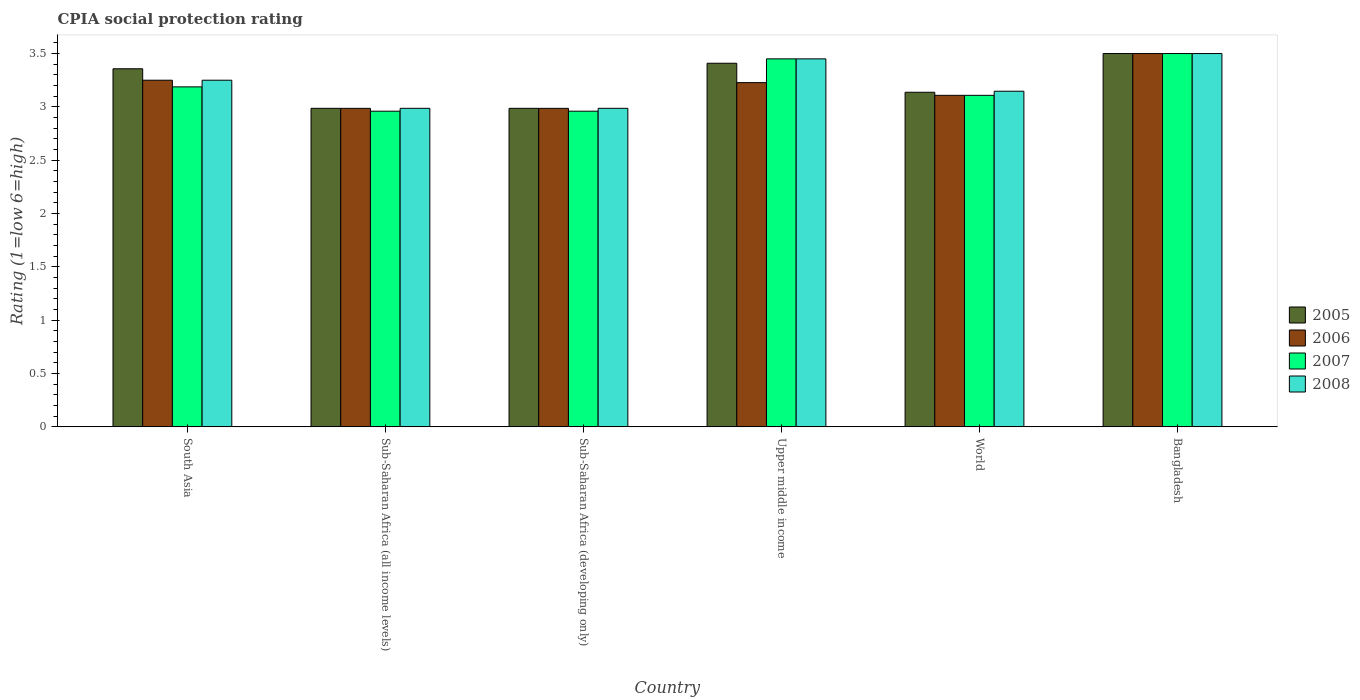Are the number of bars on each tick of the X-axis equal?
Offer a terse response. Yes. How many bars are there on the 4th tick from the right?
Offer a very short reply. 4. What is the label of the 5th group of bars from the left?
Offer a terse response. World. In how many cases, is the number of bars for a given country not equal to the number of legend labels?
Make the answer very short. 0. What is the CPIA rating in 2005 in Sub-Saharan Africa (all income levels)?
Provide a succinct answer. 2.99. Across all countries, what is the minimum CPIA rating in 2008?
Offer a very short reply. 2.99. In which country was the CPIA rating in 2005 maximum?
Your answer should be compact. Bangladesh. In which country was the CPIA rating in 2007 minimum?
Your answer should be very brief. Sub-Saharan Africa (all income levels). What is the total CPIA rating in 2008 in the graph?
Provide a succinct answer. 19.32. What is the difference between the CPIA rating in 2008 in Bangladesh and that in Sub-Saharan Africa (developing only)?
Offer a very short reply. 0.51. What is the difference between the CPIA rating in 2006 in Upper middle income and the CPIA rating in 2008 in Bangladesh?
Give a very brief answer. -0.27. What is the average CPIA rating in 2008 per country?
Ensure brevity in your answer.  3.22. What is the difference between the CPIA rating of/in 2007 and CPIA rating of/in 2006 in South Asia?
Provide a short and direct response. -0.06. In how many countries, is the CPIA rating in 2007 greater than 0.5?
Offer a terse response. 6. What is the ratio of the CPIA rating in 2006 in Bangladesh to that in Sub-Saharan Africa (all income levels)?
Give a very brief answer. 1.17. Is the CPIA rating in 2008 in Bangladesh less than that in Sub-Saharan Africa (all income levels)?
Make the answer very short. No. What is the difference between the highest and the second highest CPIA rating in 2008?
Your answer should be compact. 0.2. What is the difference between the highest and the lowest CPIA rating in 2005?
Provide a short and direct response. 0.51. Is it the case that in every country, the sum of the CPIA rating in 2005 and CPIA rating in 2006 is greater than the sum of CPIA rating in 2008 and CPIA rating in 2007?
Your answer should be very brief. No. Is it the case that in every country, the sum of the CPIA rating in 2006 and CPIA rating in 2007 is greater than the CPIA rating in 2005?
Make the answer very short. Yes. How many countries are there in the graph?
Provide a short and direct response. 6. Does the graph contain grids?
Give a very brief answer. No. Where does the legend appear in the graph?
Ensure brevity in your answer.  Center right. What is the title of the graph?
Offer a very short reply. CPIA social protection rating. What is the Rating (1=low 6=high) in 2005 in South Asia?
Make the answer very short. 3.36. What is the Rating (1=low 6=high) in 2007 in South Asia?
Keep it short and to the point. 3.19. What is the Rating (1=low 6=high) of 2005 in Sub-Saharan Africa (all income levels)?
Provide a succinct answer. 2.99. What is the Rating (1=low 6=high) in 2006 in Sub-Saharan Africa (all income levels)?
Give a very brief answer. 2.99. What is the Rating (1=low 6=high) of 2007 in Sub-Saharan Africa (all income levels)?
Offer a terse response. 2.96. What is the Rating (1=low 6=high) in 2008 in Sub-Saharan Africa (all income levels)?
Ensure brevity in your answer.  2.99. What is the Rating (1=low 6=high) of 2005 in Sub-Saharan Africa (developing only)?
Keep it short and to the point. 2.99. What is the Rating (1=low 6=high) in 2006 in Sub-Saharan Africa (developing only)?
Your response must be concise. 2.99. What is the Rating (1=low 6=high) of 2007 in Sub-Saharan Africa (developing only)?
Provide a succinct answer. 2.96. What is the Rating (1=low 6=high) in 2008 in Sub-Saharan Africa (developing only)?
Provide a short and direct response. 2.99. What is the Rating (1=low 6=high) in 2005 in Upper middle income?
Make the answer very short. 3.41. What is the Rating (1=low 6=high) in 2006 in Upper middle income?
Make the answer very short. 3.23. What is the Rating (1=low 6=high) in 2007 in Upper middle income?
Offer a terse response. 3.45. What is the Rating (1=low 6=high) of 2008 in Upper middle income?
Keep it short and to the point. 3.45. What is the Rating (1=low 6=high) in 2005 in World?
Give a very brief answer. 3.14. What is the Rating (1=low 6=high) of 2006 in World?
Ensure brevity in your answer.  3.11. What is the Rating (1=low 6=high) in 2007 in World?
Your answer should be very brief. 3.11. What is the Rating (1=low 6=high) of 2008 in World?
Offer a terse response. 3.15. What is the Rating (1=low 6=high) of 2006 in Bangladesh?
Provide a succinct answer. 3.5. Across all countries, what is the maximum Rating (1=low 6=high) of 2005?
Offer a very short reply. 3.5. Across all countries, what is the maximum Rating (1=low 6=high) in 2006?
Your answer should be very brief. 3.5. Across all countries, what is the maximum Rating (1=low 6=high) in 2008?
Offer a very short reply. 3.5. Across all countries, what is the minimum Rating (1=low 6=high) of 2005?
Make the answer very short. 2.99. Across all countries, what is the minimum Rating (1=low 6=high) in 2006?
Your answer should be compact. 2.99. Across all countries, what is the minimum Rating (1=low 6=high) in 2007?
Keep it short and to the point. 2.96. Across all countries, what is the minimum Rating (1=low 6=high) of 2008?
Ensure brevity in your answer.  2.99. What is the total Rating (1=low 6=high) of 2005 in the graph?
Your answer should be very brief. 19.38. What is the total Rating (1=low 6=high) in 2006 in the graph?
Provide a succinct answer. 19.06. What is the total Rating (1=low 6=high) in 2007 in the graph?
Give a very brief answer. 19.16. What is the total Rating (1=low 6=high) of 2008 in the graph?
Offer a terse response. 19.32. What is the difference between the Rating (1=low 6=high) in 2005 in South Asia and that in Sub-Saharan Africa (all income levels)?
Offer a very short reply. 0.37. What is the difference between the Rating (1=low 6=high) of 2006 in South Asia and that in Sub-Saharan Africa (all income levels)?
Provide a succinct answer. 0.26. What is the difference between the Rating (1=low 6=high) in 2007 in South Asia and that in Sub-Saharan Africa (all income levels)?
Make the answer very short. 0.23. What is the difference between the Rating (1=low 6=high) of 2008 in South Asia and that in Sub-Saharan Africa (all income levels)?
Your answer should be very brief. 0.26. What is the difference between the Rating (1=low 6=high) in 2005 in South Asia and that in Sub-Saharan Africa (developing only)?
Your answer should be compact. 0.37. What is the difference between the Rating (1=low 6=high) in 2006 in South Asia and that in Sub-Saharan Africa (developing only)?
Keep it short and to the point. 0.26. What is the difference between the Rating (1=low 6=high) of 2007 in South Asia and that in Sub-Saharan Africa (developing only)?
Your response must be concise. 0.23. What is the difference between the Rating (1=low 6=high) in 2008 in South Asia and that in Sub-Saharan Africa (developing only)?
Give a very brief answer. 0.26. What is the difference between the Rating (1=low 6=high) of 2005 in South Asia and that in Upper middle income?
Offer a very short reply. -0.05. What is the difference between the Rating (1=low 6=high) in 2006 in South Asia and that in Upper middle income?
Offer a terse response. 0.02. What is the difference between the Rating (1=low 6=high) of 2007 in South Asia and that in Upper middle income?
Keep it short and to the point. -0.26. What is the difference between the Rating (1=low 6=high) of 2008 in South Asia and that in Upper middle income?
Offer a very short reply. -0.2. What is the difference between the Rating (1=low 6=high) in 2005 in South Asia and that in World?
Offer a terse response. 0.22. What is the difference between the Rating (1=low 6=high) in 2006 in South Asia and that in World?
Ensure brevity in your answer.  0.14. What is the difference between the Rating (1=low 6=high) of 2007 in South Asia and that in World?
Offer a terse response. 0.08. What is the difference between the Rating (1=low 6=high) of 2008 in South Asia and that in World?
Ensure brevity in your answer.  0.1. What is the difference between the Rating (1=low 6=high) of 2005 in South Asia and that in Bangladesh?
Offer a terse response. -0.14. What is the difference between the Rating (1=low 6=high) of 2006 in South Asia and that in Bangladesh?
Your response must be concise. -0.25. What is the difference between the Rating (1=low 6=high) of 2007 in South Asia and that in Bangladesh?
Provide a succinct answer. -0.31. What is the difference between the Rating (1=low 6=high) in 2008 in South Asia and that in Bangladesh?
Make the answer very short. -0.25. What is the difference between the Rating (1=low 6=high) in 2005 in Sub-Saharan Africa (all income levels) and that in Sub-Saharan Africa (developing only)?
Your response must be concise. 0. What is the difference between the Rating (1=low 6=high) of 2006 in Sub-Saharan Africa (all income levels) and that in Sub-Saharan Africa (developing only)?
Offer a very short reply. 0. What is the difference between the Rating (1=low 6=high) of 2005 in Sub-Saharan Africa (all income levels) and that in Upper middle income?
Keep it short and to the point. -0.42. What is the difference between the Rating (1=low 6=high) in 2006 in Sub-Saharan Africa (all income levels) and that in Upper middle income?
Ensure brevity in your answer.  -0.24. What is the difference between the Rating (1=low 6=high) in 2007 in Sub-Saharan Africa (all income levels) and that in Upper middle income?
Your response must be concise. -0.49. What is the difference between the Rating (1=low 6=high) of 2008 in Sub-Saharan Africa (all income levels) and that in Upper middle income?
Your response must be concise. -0.46. What is the difference between the Rating (1=low 6=high) of 2005 in Sub-Saharan Africa (all income levels) and that in World?
Your answer should be very brief. -0.15. What is the difference between the Rating (1=low 6=high) in 2006 in Sub-Saharan Africa (all income levels) and that in World?
Give a very brief answer. -0.12. What is the difference between the Rating (1=low 6=high) of 2007 in Sub-Saharan Africa (all income levels) and that in World?
Provide a short and direct response. -0.15. What is the difference between the Rating (1=low 6=high) in 2008 in Sub-Saharan Africa (all income levels) and that in World?
Your response must be concise. -0.16. What is the difference between the Rating (1=low 6=high) in 2005 in Sub-Saharan Africa (all income levels) and that in Bangladesh?
Ensure brevity in your answer.  -0.51. What is the difference between the Rating (1=low 6=high) in 2006 in Sub-Saharan Africa (all income levels) and that in Bangladesh?
Your answer should be very brief. -0.51. What is the difference between the Rating (1=low 6=high) of 2007 in Sub-Saharan Africa (all income levels) and that in Bangladesh?
Provide a short and direct response. -0.54. What is the difference between the Rating (1=low 6=high) of 2008 in Sub-Saharan Africa (all income levels) and that in Bangladesh?
Ensure brevity in your answer.  -0.51. What is the difference between the Rating (1=low 6=high) in 2005 in Sub-Saharan Africa (developing only) and that in Upper middle income?
Your response must be concise. -0.42. What is the difference between the Rating (1=low 6=high) of 2006 in Sub-Saharan Africa (developing only) and that in Upper middle income?
Make the answer very short. -0.24. What is the difference between the Rating (1=low 6=high) in 2007 in Sub-Saharan Africa (developing only) and that in Upper middle income?
Your answer should be compact. -0.49. What is the difference between the Rating (1=low 6=high) in 2008 in Sub-Saharan Africa (developing only) and that in Upper middle income?
Provide a succinct answer. -0.46. What is the difference between the Rating (1=low 6=high) in 2005 in Sub-Saharan Africa (developing only) and that in World?
Give a very brief answer. -0.15. What is the difference between the Rating (1=low 6=high) in 2006 in Sub-Saharan Africa (developing only) and that in World?
Make the answer very short. -0.12. What is the difference between the Rating (1=low 6=high) of 2007 in Sub-Saharan Africa (developing only) and that in World?
Offer a terse response. -0.15. What is the difference between the Rating (1=low 6=high) of 2008 in Sub-Saharan Africa (developing only) and that in World?
Keep it short and to the point. -0.16. What is the difference between the Rating (1=low 6=high) of 2005 in Sub-Saharan Africa (developing only) and that in Bangladesh?
Your answer should be very brief. -0.51. What is the difference between the Rating (1=low 6=high) in 2006 in Sub-Saharan Africa (developing only) and that in Bangladesh?
Give a very brief answer. -0.51. What is the difference between the Rating (1=low 6=high) of 2007 in Sub-Saharan Africa (developing only) and that in Bangladesh?
Your response must be concise. -0.54. What is the difference between the Rating (1=low 6=high) of 2008 in Sub-Saharan Africa (developing only) and that in Bangladesh?
Make the answer very short. -0.51. What is the difference between the Rating (1=low 6=high) in 2005 in Upper middle income and that in World?
Offer a very short reply. 0.27. What is the difference between the Rating (1=low 6=high) in 2006 in Upper middle income and that in World?
Offer a very short reply. 0.12. What is the difference between the Rating (1=low 6=high) in 2007 in Upper middle income and that in World?
Ensure brevity in your answer.  0.34. What is the difference between the Rating (1=low 6=high) of 2008 in Upper middle income and that in World?
Make the answer very short. 0.3. What is the difference between the Rating (1=low 6=high) of 2005 in Upper middle income and that in Bangladesh?
Keep it short and to the point. -0.09. What is the difference between the Rating (1=low 6=high) in 2006 in Upper middle income and that in Bangladesh?
Keep it short and to the point. -0.27. What is the difference between the Rating (1=low 6=high) in 2005 in World and that in Bangladesh?
Your response must be concise. -0.36. What is the difference between the Rating (1=low 6=high) in 2006 in World and that in Bangladesh?
Keep it short and to the point. -0.39. What is the difference between the Rating (1=low 6=high) in 2007 in World and that in Bangladesh?
Your answer should be very brief. -0.39. What is the difference between the Rating (1=low 6=high) in 2008 in World and that in Bangladesh?
Give a very brief answer. -0.35. What is the difference between the Rating (1=low 6=high) in 2005 in South Asia and the Rating (1=low 6=high) in 2006 in Sub-Saharan Africa (all income levels)?
Your answer should be compact. 0.37. What is the difference between the Rating (1=low 6=high) in 2005 in South Asia and the Rating (1=low 6=high) in 2007 in Sub-Saharan Africa (all income levels)?
Your response must be concise. 0.4. What is the difference between the Rating (1=low 6=high) of 2005 in South Asia and the Rating (1=low 6=high) of 2008 in Sub-Saharan Africa (all income levels)?
Give a very brief answer. 0.37. What is the difference between the Rating (1=low 6=high) in 2006 in South Asia and the Rating (1=low 6=high) in 2007 in Sub-Saharan Africa (all income levels)?
Your answer should be compact. 0.29. What is the difference between the Rating (1=low 6=high) of 2006 in South Asia and the Rating (1=low 6=high) of 2008 in Sub-Saharan Africa (all income levels)?
Offer a terse response. 0.26. What is the difference between the Rating (1=low 6=high) of 2007 in South Asia and the Rating (1=low 6=high) of 2008 in Sub-Saharan Africa (all income levels)?
Offer a very short reply. 0.2. What is the difference between the Rating (1=low 6=high) of 2005 in South Asia and the Rating (1=low 6=high) of 2006 in Sub-Saharan Africa (developing only)?
Give a very brief answer. 0.37. What is the difference between the Rating (1=low 6=high) of 2005 in South Asia and the Rating (1=low 6=high) of 2007 in Sub-Saharan Africa (developing only)?
Your answer should be compact. 0.4. What is the difference between the Rating (1=low 6=high) in 2005 in South Asia and the Rating (1=low 6=high) in 2008 in Sub-Saharan Africa (developing only)?
Offer a very short reply. 0.37. What is the difference between the Rating (1=low 6=high) of 2006 in South Asia and the Rating (1=low 6=high) of 2007 in Sub-Saharan Africa (developing only)?
Make the answer very short. 0.29. What is the difference between the Rating (1=low 6=high) of 2006 in South Asia and the Rating (1=low 6=high) of 2008 in Sub-Saharan Africa (developing only)?
Provide a short and direct response. 0.26. What is the difference between the Rating (1=low 6=high) of 2007 in South Asia and the Rating (1=low 6=high) of 2008 in Sub-Saharan Africa (developing only)?
Offer a terse response. 0.2. What is the difference between the Rating (1=low 6=high) in 2005 in South Asia and the Rating (1=low 6=high) in 2006 in Upper middle income?
Offer a terse response. 0.13. What is the difference between the Rating (1=low 6=high) of 2005 in South Asia and the Rating (1=low 6=high) of 2007 in Upper middle income?
Offer a very short reply. -0.09. What is the difference between the Rating (1=low 6=high) in 2005 in South Asia and the Rating (1=low 6=high) in 2008 in Upper middle income?
Keep it short and to the point. -0.09. What is the difference between the Rating (1=low 6=high) of 2006 in South Asia and the Rating (1=low 6=high) of 2007 in Upper middle income?
Offer a very short reply. -0.2. What is the difference between the Rating (1=low 6=high) in 2007 in South Asia and the Rating (1=low 6=high) in 2008 in Upper middle income?
Your answer should be compact. -0.26. What is the difference between the Rating (1=low 6=high) of 2005 in South Asia and the Rating (1=low 6=high) of 2006 in World?
Your answer should be compact. 0.25. What is the difference between the Rating (1=low 6=high) in 2005 in South Asia and the Rating (1=low 6=high) in 2007 in World?
Offer a terse response. 0.25. What is the difference between the Rating (1=low 6=high) in 2005 in South Asia and the Rating (1=low 6=high) in 2008 in World?
Give a very brief answer. 0.21. What is the difference between the Rating (1=low 6=high) of 2006 in South Asia and the Rating (1=low 6=high) of 2007 in World?
Your answer should be compact. 0.14. What is the difference between the Rating (1=low 6=high) of 2006 in South Asia and the Rating (1=low 6=high) of 2008 in World?
Keep it short and to the point. 0.1. What is the difference between the Rating (1=low 6=high) of 2007 in South Asia and the Rating (1=low 6=high) of 2008 in World?
Your answer should be compact. 0.04. What is the difference between the Rating (1=low 6=high) in 2005 in South Asia and the Rating (1=low 6=high) in 2006 in Bangladesh?
Make the answer very short. -0.14. What is the difference between the Rating (1=low 6=high) in 2005 in South Asia and the Rating (1=low 6=high) in 2007 in Bangladesh?
Make the answer very short. -0.14. What is the difference between the Rating (1=low 6=high) in 2005 in South Asia and the Rating (1=low 6=high) in 2008 in Bangladesh?
Keep it short and to the point. -0.14. What is the difference between the Rating (1=low 6=high) in 2006 in South Asia and the Rating (1=low 6=high) in 2007 in Bangladesh?
Offer a terse response. -0.25. What is the difference between the Rating (1=low 6=high) in 2006 in South Asia and the Rating (1=low 6=high) in 2008 in Bangladesh?
Offer a very short reply. -0.25. What is the difference between the Rating (1=low 6=high) of 2007 in South Asia and the Rating (1=low 6=high) of 2008 in Bangladesh?
Keep it short and to the point. -0.31. What is the difference between the Rating (1=low 6=high) of 2005 in Sub-Saharan Africa (all income levels) and the Rating (1=low 6=high) of 2006 in Sub-Saharan Africa (developing only)?
Your response must be concise. 0. What is the difference between the Rating (1=low 6=high) in 2005 in Sub-Saharan Africa (all income levels) and the Rating (1=low 6=high) in 2007 in Sub-Saharan Africa (developing only)?
Your answer should be very brief. 0.03. What is the difference between the Rating (1=low 6=high) of 2005 in Sub-Saharan Africa (all income levels) and the Rating (1=low 6=high) of 2008 in Sub-Saharan Africa (developing only)?
Keep it short and to the point. 0. What is the difference between the Rating (1=low 6=high) of 2006 in Sub-Saharan Africa (all income levels) and the Rating (1=low 6=high) of 2007 in Sub-Saharan Africa (developing only)?
Offer a very short reply. 0.03. What is the difference between the Rating (1=low 6=high) of 2006 in Sub-Saharan Africa (all income levels) and the Rating (1=low 6=high) of 2008 in Sub-Saharan Africa (developing only)?
Offer a terse response. -0. What is the difference between the Rating (1=low 6=high) of 2007 in Sub-Saharan Africa (all income levels) and the Rating (1=low 6=high) of 2008 in Sub-Saharan Africa (developing only)?
Ensure brevity in your answer.  -0.03. What is the difference between the Rating (1=low 6=high) of 2005 in Sub-Saharan Africa (all income levels) and the Rating (1=low 6=high) of 2006 in Upper middle income?
Make the answer very short. -0.24. What is the difference between the Rating (1=low 6=high) in 2005 in Sub-Saharan Africa (all income levels) and the Rating (1=low 6=high) in 2007 in Upper middle income?
Provide a short and direct response. -0.46. What is the difference between the Rating (1=low 6=high) of 2005 in Sub-Saharan Africa (all income levels) and the Rating (1=low 6=high) of 2008 in Upper middle income?
Make the answer very short. -0.46. What is the difference between the Rating (1=low 6=high) in 2006 in Sub-Saharan Africa (all income levels) and the Rating (1=low 6=high) in 2007 in Upper middle income?
Keep it short and to the point. -0.46. What is the difference between the Rating (1=low 6=high) of 2006 in Sub-Saharan Africa (all income levels) and the Rating (1=low 6=high) of 2008 in Upper middle income?
Ensure brevity in your answer.  -0.46. What is the difference between the Rating (1=low 6=high) of 2007 in Sub-Saharan Africa (all income levels) and the Rating (1=low 6=high) of 2008 in Upper middle income?
Your answer should be compact. -0.49. What is the difference between the Rating (1=low 6=high) of 2005 in Sub-Saharan Africa (all income levels) and the Rating (1=low 6=high) of 2006 in World?
Keep it short and to the point. -0.12. What is the difference between the Rating (1=low 6=high) in 2005 in Sub-Saharan Africa (all income levels) and the Rating (1=low 6=high) in 2007 in World?
Your response must be concise. -0.12. What is the difference between the Rating (1=low 6=high) of 2005 in Sub-Saharan Africa (all income levels) and the Rating (1=low 6=high) of 2008 in World?
Keep it short and to the point. -0.16. What is the difference between the Rating (1=low 6=high) of 2006 in Sub-Saharan Africa (all income levels) and the Rating (1=low 6=high) of 2007 in World?
Offer a very short reply. -0.12. What is the difference between the Rating (1=low 6=high) in 2006 in Sub-Saharan Africa (all income levels) and the Rating (1=low 6=high) in 2008 in World?
Your response must be concise. -0.16. What is the difference between the Rating (1=low 6=high) of 2007 in Sub-Saharan Africa (all income levels) and the Rating (1=low 6=high) of 2008 in World?
Ensure brevity in your answer.  -0.19. What is the difference between the Rating (1=low 6=high) in 2005 in Sub-Saharan Africa (all income levels) and the Rating (1=low 6=high) in 2006 in Bangladesh?
Offer a terse response. -0.51. What is the difference between the Rating (1=low 6=high) in 2005 in Sub-Saharan Africa (all income levels) and the Rating (1=low 6=high) in 2007 in Bangladesh?
Offer a very short reply. -0.51. What is the difference between the Rating (1=low 6=high) of 2005 in Sub-Saharan Africa (all income levels) and the Rating (1=low 6=high) of 2008 in Bangladesh?
Ensure brevity in your answer.  -0.51. What is the difference between the Rating (1=low 6=high) in 2006 in Sub-Saharan Africa (all income levels) and the Rating (1=low 6=high) in 2007 in Bangladesh?
Your answer should be compact. -0.51. What is the difference between the Rating (1=low 6=high) in 2006 in Sub-Saharan Africa (all income levels) and the Rating (1=low 6=high) in 2008 in Bangladesh?
Offer a terse response. -0.51. What is the difference between the Rating (1=low 6=high) of 2007 in Sub-Saharan Africa (all income levels) and the Rating (1=low 6=high) of 2008 in Bangladesh?
Provide a succinct answer. -0.54. What is the difference between the Rating (1=low 6=high) in 2005 in Sub-Saharan Africa (developing only) and the Rating (1=low 6=high) in 2006 in Upper middle income?
Ensure brevity in your answer.  -0.24. What is the difference between the Rating (1=low 6=high) of 2005 in Sub-Saharan Africa (developing only) and the Rating (1=low 6=high) of 2007 in Upper middle income?
Offer a terse response. -0.46. What is the difference between the Rating (1=low 6=high) in 2005 in Sub-Saharan Africa (developing only) and the Rating (1=low 6=high) in 2008 in Upper middle income?
Your answer should be very brief. -0.46. What is the difference between the Rating (1=low 6=high) in 2006 in Sub-Saharan Africa (developing only) and the Rating (1=low 6=high) in 2007 in Upper middle income?
Provide a short and direct response. -0.46. What is the difference between the Rating (1=low 6=high) of 2006 in Sub-Saharan Africa (developing only) and the Rating (1=low 6=high) of 2008 in Upper middle income?
Provide a short and direct response. -0.46. What is the difference between the Rating (1=low 6=high) in 2007 in Sub-Saharan Africa (developing only) and the Rating (1=low 6=high) in 2008 in Upper middle income?
Make the answer very short. -0.49. What is the difference between the Rating (1=low 6=high) of 2005 in Sub-Saharan Africa (developing only) and the Rating (1=low 6=high) of 2006 in World?
Provide a short and direct response. -0.12. What is the difference between the Rating (1=low 6=high) of 2005 in Sub-Saharan Africa (developing only) and the Rating (1=low 6=high) of 2007 in World?
Ensure brevity in your answer.  -0.12. What is the difference between the Rating (1=low 6=high) in 2005 in Sub-Saharan Africa (developing only) and the Rating (1=low 6=high) in 2008 in World?
Make the answer very short. -0.16. What is the difference between the Rating (1=low 6=high) in 2006 in Sub-Saharan Africa (developing only) and the Rating (1=low 6=high) in 2007 in World?
Offer a terse response. -0.12. What is the difference between the Rating (1=low 6=high) in 2006 in Sub-Saharan Africa (developing only) and the Rating (1=low 6=high) in 2008 in World?
Give a very brief answer. -0.16. What is the difference between the Rating (1=low 6=high) of 2007 in Sub-Saharan Africa (developing only) and the Rating (1=low 6=high) of 2008 in World?
Offer a very short reply. -0.19. What is the difference between the Rating (1=low 6=high) of 2005 in Sub-Saharan Africa (developing only) and the Rating (1=low 6=high) of 2006 in Bangladesh?
Your answer should be very brief. -0.51. What is the difference between the Rating (1=low 6=high) in 2005 in Sub-Saharan Africa (developing only) and the Rating (1=low 6=high) in 2007 in Bangladesh?
Ensure brevity in your answer.  -0.51. What is the difference between the Rating (1=low 6=high) in 2005 in Sub-Saharan Africa (developing only) and the Rating (1=low 6=high) in 2008 in Bangladesh?
Provide a short and direct response. -0.51. What is the difference between the Rating (1=low 6=high) in 2006 in Sub-Saharan Africa (developing only) and the Rating (1=low 6=high) in 2007 in Bangladesh?
Your response must be concise. -0.51. What is the difference between the Rating (1=low 6=high) of 2006 in Sub-Saharan Africa (developing only) and the Rating (1=low 6=high) of 2008 in Bangladesh?
Provide a succinct answer. -0.51. What is the difference between the Rating (1=low 6=high) of 2007 in Sub-Saharan Africa (developing only) and the Rating (1=low 6=high) of 2008 in Bangladesh?
Provide a short and direct response. -0.54. What is the difference between the Rating (1=low 6=high) of 2005 in Upper middle income and the Rating (1=low 6=high) of 2006 in World?
Your response must be concise. 0.3. What is the difference between the Rating (1=low 6=high) of 2005 in Upper middle income and the Rating (1=low 6=high) of 2007 in World?
Make the answer very short. 0.3. What is the difference between the Rating (1=low 6=high) of 2005 in Upper middle income and the Rating (1=low 6=high) of 2008 in World?
Ensure brevity in your answer.  0.26. What is the difference between the Rating (1=low 6=high) of 2006 in Upper middle income and the Rating (1=low 6=high) of 2007 in World?
Make the answer very short. 0.12. What is the difference between the Rating (1=low 6=high) in 2006 in Upper middle income and the Rating (1=low 6=high) in 2008 in World?
Offer a terse response. 0.08. What is the difference between the Rating (1=low 6=high) in 2007 in Upper middle income and the Rating (1=low 6=high) in 2008 in World?
Keep it short and to the point. 0.3. What is the difference between the Rating (1=low 6=high) of 2005 in Upper middle income and the Rating (1=low 6=high) of 2006 in Bangladesh?
Make the answer very short. -0.09. What is the difference between the Rating (1=low 6=high) of 2005 in Upper middle income and the Rating (1=low 6=high) of 2007 in Bangladesh?
Provide a succinct answer. -0.09. What is the difference between the Rating (1=low 6=high) in 2005 in Upper middle income and the Rating (1=low 6=high) in 2008 in Bangladesh?
Ensure brevity in your answer.  -0.09. What is the difference between the Rating (1=low 6=high) in 2006 in Upper middle income and the Rating (1=low 6=high) in 2007 in Bangladesh?
Provide a succinct answer. -0.27. What is the difference between the Rating (1=low 6=high) of 2006 in Upper middle income and the Rating (1=low 6=high) of 2008 in Bangladesh?
Provide a succinct answer. -0.27. What is the difference between the Rating (1=low 6=high) in 2007 in Upper middle income and the Rating (1=low 6=high) in 2008 in Bangladesh?
Your answer should be compact. -0.05. What is the difference between the Rating (1=low 6=high) of 2005 in World and the Rating (1=low 6=high) of 2006 in Bangladesh?
Keep it short and to the point. -0.36. What is the difference between the Rating (1=low 6=high) in 2005 in World and the Rating (1=low 6=high) in 2007 in Bangladesh?
Make the answer very short. -0.36. What is the difference between the Rating (1=low 6=high) in 2005 in World and the Rating (1=low 6=high) in 2008 in Bangladesh?
Offer a very short reply. -0.36. What is the difference between the Rating (1=low 6=high) in 2006 in World and the Rating (1=low 6=high) in 2007 in Bangladesh?
Your answer should be compact. -0.39. What is the difference between the Rating (1=low 6=high) in 2006 in World and the Rating (1=low 6=high) in 2008 in Bangladesh?
Make the answer very short. -0.39. What is the difference between the Rating (1=low 6=high) of 2007 in World and the Rating (1=low 6=high) of 2008 in Bangladesh?
Your answer should be very brief. -0.39. What is the average Rating (1=low 6=high) in 2005 per country?
Provide a short and direct response. 3.23. What is the average Rating (1=low 6=high) of 2006 per country?
Keep it short and to the point. 3.18. What is the average Rating (1=low 6=high) in 2007 per country?
Give a very brief answer. 3.19. What is the average Rating (1=low 6=high) of 2008 per country?
Offer a terse response. 3.22. What is the difference between the Rating (1=low 6=high) in 2005 and Rating (1=low 6=high) in 2006 in South Asia?
Your answer should be compact. 0.11. What is the difference between the Rating (1=low 6=high) in 2005 and Rating (1=low 6=high) in 2007 in South Asia?
Offer a terse response. 0.17. What is the difference between the Rating (1=low 6=high) of 2005 and Rating (1=low 6=high) of 2008 in South Asia?
Offer a terse response. 0.11. What is the difference between the Rating (1=low 6=high) of 2006 and Rating (1=low 6=high) of 2007 in South Asia?
Give a very brief answer. 0.06. What is the difference between the Rating (1=low 6=high) in 2006 and Rating (1=low 6=high) in 2008 in South Asia?
Your answer should be compact. 0. What is the difference between the Rating (1=low 6=high) in 2007 and Rating (1=low 6=high) in 2008 in South Asia?
Ensure brevity in your answer.  -0.06. What is the difference between the Rating (1=low 6=high) in 2005 and Rating (1=low 6=high) in 2007 in Sub-Saharan Africa (all income levels)?
Your answer should be compact. 0.03. What is the difference between the Rating (1=low 6=high) in 2005 and Rating (1=low 6=high) in 2008 in Sub-Saharan Africa (all income levels)?
Your answer should be compact. 0. What is the difference between the Rating (1=low 6=high) of 2006 and Rating (1=low 6=high) of 2007 in Sub-Saharan Africa (all income levels)?
Provide a short and direct response. 0.03. What is the difference between the Rating (1=low 6=high) of 2006 and Rating (1=low 6=high) of 2008 in Sub-Saharan Africa (all income levels)?
Offer a terse response. -0. What is the difference between the Rating (1=low 6=high) of 2007 and Rating (1=low 6=high) of 2008 in Sub-Saharan Africa (all income levels)?
Your answer should be compact. -0.03. What is the difference between the Rating (1=low 6=high) of 2005 and Rating (1=low 6=high) of 2007 in Sub-Saharan Africa (developing only)?
Provide a succinct answer. 0.03. What is the difference between the Rating (1=low 6=high) of 2005 and Rating (1=low 6=high) of 2008 in Sub-Saharan Africa (developing only)?
Keep it short and to the point. 0. What is the difference between the Rating (1=low 6=high) in 2006 and Rating (1=low 6=high) in 2007 in Sub-Saharan Africa (developing only)?
Offer a terse response. 0.03. What is the difference between the Rating (1=low 6=high) of 2006 and Rating (1=low 6=high) of 2008 in Sub-Saharan Africa (developing only)?
Your response must be concise. -0. What is the difference between the Rating (1=low 6=high) of 2007 and Rating (1=low 6=high) of 2008 in Sub-Saharan Africa (developing only)?
Offer a terse response. -0.03. What is the difference between the Rating (1=low 6=high) of 2005 and Rating (1=low 6=high) of 2006 in Upper middle income?
Ensure brevity in your answer.  0.18. What is the difference between the Rating (1=low 6=high) in 2005 and Rating (1=low 6=high) in 2007 in Upper middle income?
Keep it short and to the point. -0.04. What is the difference between the Rating (1=low 6=high) of 2005 and Rating (1=low 6=high) of 2008 in Upper middle income?
Your response must be concise. -0.04. What is the difference between the Rating (1=low 6=high) in 2006 and Rating (1=low 6=high) in 2007 in Upper middle income?
Offer a very short reply. -0.22. What is the difference between the Rating (1=low 6=high) of 2006 and Rating (1=low 6=high) of 2008 in Upper middle income?
Make the answer very short. -0.22. What is the difference between the Rating (1=low 6=high) of 2007 and Rating (1=low 6=high) of 2008 in Upper middle income?
Ensure brevity in your answer.  0. What is the difference between the Rating (1=low 6=high) in 2005 and Rating (1=low 6=high) in 2006 in World?
Your answer should be compact. 0.03. What is the difference between the Rating (1=low 6=high) in 2005 and Rating (1=low 6=high) in 2007 in World?
Ensure brevity in your answer.  0.03. What is the difference between the Rating (1=low 6=high) of 2005 and Rating (1=low 6=high) of 2008 in World?
Provide a succinct answer. -0.01. What is the difference between the Rating (1=low 6=high) in 2006 and Rating (1=low 6=high) in 2007 in World?
Provide a succinct answer. 0. What is the difference between the Rating (1=low 6=high) in 2006 and Rating (1=low 6=high) in 2008 in World?
Your answer should be compact. -0.04. What is the difference between the Rating (1=low 6=high) of 2007 and Rating (1=low 6=high) of 2008 in World?
Ensure brevity in your answer.  -0.04. What is the difference between the Rating (1=low 6=high) of 2005 and Rating (1=low 6=high) of 2006 in Bangladesh?
Provide a succinct answer. 0. What is the difference between the Rating (1=low 6=high) in 2005 and Rating (1=low 6=high) in 2007 in Bangladesh?
Ensure brevity in your answer.  0. What is the difference between the Rating (1=low 6=high) in 2005 and Rating (1=low 6=high) in 2008 in Bangladesh?
Your answer should be very brief. 0. What is the difference between the Rating (1=low 6=high) of 2007 and Rating (1=low 6=high) of 2008 in Bangladesh?
Your response must be concise. 0. What is the ratio of the Rating (1=low 6=high) in 2005 in South Asia to that in Sub-Saharan Africa (all income levels)?
Offer a terse response. 1.12. What is the ratio of the Rating (1=low 6=high) in 2006 in South Asia to that in Sub-Saharan Africa (all income levels)?
Your response must be concise. 1.09. What is the ratio of the Rating (1=low 6=high) in 2007 in South Asia to that in Sub-Saharan Africa (all income levels)?
Provide a short and direct response. 1.08. What is the ratio of the Rating (1=low 6=high) of 2008 in South Asia to that in Sub-Saharan Africa (all income levels)?
Ensure brevity in your answer.  1.09. What is the ratio of the Rating (1=low 6=high) of 2005 in South Asia to that in Sub-Saharan Africa (developing only)?
Offer a very short reply. 1.12. What is the ratio of the Rating (1=low 6=high) in 2006 in South Asia to that in Sub-Saharan Africa (developing only)?
Offer a terse response. 1.09. What is the ratio of the Rating (1=low 6=high) of 2007 in South Asia to that in Sub-Saharan Africa (developing only)?
Provide a short and direct response. 1.08. What is the ratio of the Rating (1=low 6=high) of 2008 in South Asia to that in Sub-Saharan Africa (developing only)?
Provide a short and direct response. 1.09. What is the ratio of the Rating (1=low 6=high) in 2006 in South Asia to that in Upper middle income?
Your answer should be compact. 1.01. What is the ratio of the Rating (1=low 6=high) of 2007 in South Asia to that in Upper middle income?
Provide a short and direct response. 0.92. What is the ratio of the Rating (1=low 6=high) in 2008 in South Asia to that in Upper middle income?
Your answer should be compact. 0.94. What is the ratio of the Rating (1=low 6=high) of 2005 in South Asia to that in World?
Ensure brevity in your answer.  1.07. What is the ratio of the Rating (1=low 6=high) of 2006 in South Asia to that in World?
Keep it short and to the point. 1.05. What is the ratio of the Rating (1=low 6=high) in 2007 in South Asia to that in World?
Keep it short and to the point. 1.03. What is the ratio of the Rating (1=low 6=high) of 2008 in South Asia to that in World?
Provide a succinct answer. 1.03. What is the ratio of the Rating (1=low 6=high) in 2005 in South Asia to that in Bangladesh?
Make the answer very short. 0.96. What is the ratio of the Rating (1=low 6=high) in 2007 in South Asia to that in Bangladesh?
Provide a succinct answer. 0.91. What is the ratio of the Rating (1=low 6=high) of 2006 in Sub-Saharan Africa (all income levels) to that in Sub-Saharan Africa (developing only)?
Your answer should be very brief. 1. What is the ratio of the Rating (1=low 6=high) of 2005 in Sub-Saharan Africa (all income levels) to that in Upper middle income?
Your answer should be compact. 0.88. What is the ratio of the Rating (1=low 6=high) in 2006 in Sub-Saharan Africa (all income levels) to that in Upper middle income?
Your answer should be very brief. 0.93. What is the ratio of the Rating (1=low 6=high) of 2007 in Sub-Saharan Africa (all income levels) to that in Upper middle income?
Make the answer very short. 0.86. What is the ratio of the Rating (1=low 6=high) in 2008 in Sub-Saharan Africa (all income levels) to that in Upper middle income?
Make the answer very short. 0.87. What is the ratio of the Rating (1=low 6=high) in 2005 in Sub-Saharan Africa (all income levels) to that in World?
Provide a short and direct response. 0.95. What is the ratio of the Rating (1=low 6=high) of 2006 in Sub-Saharan Africa (all income levels) to that in World?
Make the answer very short. 0.96. What is the ratio of the Rating (1=low 6=high) in 2007 in Sub-Saharan Africa (all income levels) to that in World?
Give a very brief answer. 0.95. What is the ratio of the Rating (1=low 6=high) in 2008 in Sub-Saharan Africa (all income levels) to that in World?
Your response must be concise. 0.95. What is the ratio of the Rating (1=low 6=high) in 2005 in Sub-Saharan Africa (all income levels) to that in Bangladesh?
Ensure brevity in your answer.  0.85. What is the ratio of the Rating (1=low 6=high) in 2006 in Sub-Saharan Africa (all income levels) to that in Bangladesh?
Your answer should be very brief. 0.85. What is the ratio of the Rating (1=low 6=high) of 2007 in Sub-Saharan Africa (all income levels) to that in Bangladesh?
Provide a succinct answer. 0.85. What is the ratio of the Rating (1=low 6=high) of 2008 in Sub-Saharan Africa (all income levels) to that in Bangladesh?
Offer a very short reply. 0.85. What is the ratio of the Rating (1=low 6=high) in 2005 in Sub-Saharan Africa (developing only) to that in Upper middle income?
Give a very brief answer. 0.88. What is the ratio of the Rating (1=low 6=high) in 2006 in Sub-Saharan Africa (developing only) to that in Upper middle income?
Ensure brevity in your answer.  0.93. What is the ratio of the Rating (1=low 6=high) in 2007 in Sub-Saharan Africa (developing only) to that in Upper middle income?
Keep it short and to the point. 0.86. What is the ratio of the Rating (1=low 6=high) of 2008 in Sub-Saharan Africa (developing only) to that in Upper middle income?
Provide a succinct answer. 0.87. What is the ratio of the Rating (1=low 6=high) of 2006 in Sub-Saharan Africa (developing only) to that in World?
Your answer should be very brief. 0.96. What is the ratio of the Rating (1=low 6=high) of 2007 in Sub-Saharan Africa (developing only) to that in World?
Make the answer very short. 0.95. What is the ratio of the Rating (1=low 6=high) in 2008 in Sub-Saharan Africa (developing only) to that in World?
Your answer should be very brief. 0.95. What is the ratio of the Rating (1=low 6=high) in 2005 in Sub-Saharan Africa (developing only) to that in Bangladesh?
Provide a short and direct response. 0.85. What is the ratio of the Rating (1=low 6=high) of 2006 in Sub-Saharan Africa (developing only) to that in Bangladesh?
Offer a very short reply. 0.85. What is the ratio of the Rating (1=low 6=high) in 2007 in Sub-Saharan Africa (developing only) to that in Bangladesh?
Your answer should be very brief. 0.85. What is the ratio of the Rating (1=low 6=high) of 2008 in Sub-Saharan Africa (developing only) to that in Bangladesh?
Your answer should be compact. 0.85. What is the ratio of the Rating (1=low 6=high) of 2005 in Upper middle income to that in World?
Your response must be concise. 1.09. What is the ratio of the Rating (1=low 6=high) in 2006 in Upper middle income to that in World?
Offer a very short reply. 1.04. What is the ratio of the Rating (1=low 6=high) in 2007 in Upper middle income to that in World?
Your response must be concise. 1.11. What is the ratio of the Rating (1=low 6=high) of 2008 in Upper middle income to that in World?
Provide a short and direct response. 1.1. What is the ratio of the Rating (1=low 6=high) in 2005 in Upper middle income to that in Bangladesh?
Provide a succinct answer. 0.97. What is the ratio of the Rating (1=low 6=high) of 2006 in Upper middle income to that in Bangladesh?
Make the answer very short. 0.92. What is the ratio of the Rating (1=low 6=high) in 2007 in Upper middle income to that in Bangladesh?
Provide a short and direct response. 0.99. What is the ratio of the Rating (1=low 6=high) of 2008 in Upper middle income to that in Bangladesh?
Ensure brevity in your answer.  0.99. What is the ratio of the Rating (1=low 6=high) in 2005 in World to that in Bangladesh?
Provide a short and direct response. 0.9. What is the ratio of the Rating (1=low 6=high) in 2006 in World to that in Bangladesh?
Keep it short and to the point. 0.89. What is the ratio of the Rating (1=low 6=high) of 2007 in World to that in Bangladesh?
Ensure brevity in your answer.  0.89. What is the ratio of the Rating (1=low 6=high) of 2008 in World to that in Bangladesh?
Your response must be concise. 0.9. What is the difference between the highest and the second highest Rating (1=low 6=high) of 2005?
Provide a short and direct response. 0.09. What is the difference between the highest and the second highest Rating (1=low 6=high) of 2007?
Offer a very short reply. 0.05. What is the difference between the highest and the second highest Rating (1=low 6=high) in 2008?
Provide a short and direct response. 0.05. What is the difference between the highest and the lowest Rating (1=low 6=high) in 2005?
Your answer should be compact. 0.51. What is the difference between the highest and the lowest Rating (1=low 6=high) of 2006?
Keep it short and to the point. 0.51. What is the difference between the highest and the lowest Rating (1=low 6=high) in 2007?
Provide a short and direct response. 0.54. What is the difference between the highest and the lowest Rating (1=low 6=high) in 2008?
Your answer should be very brief. 0.51. 